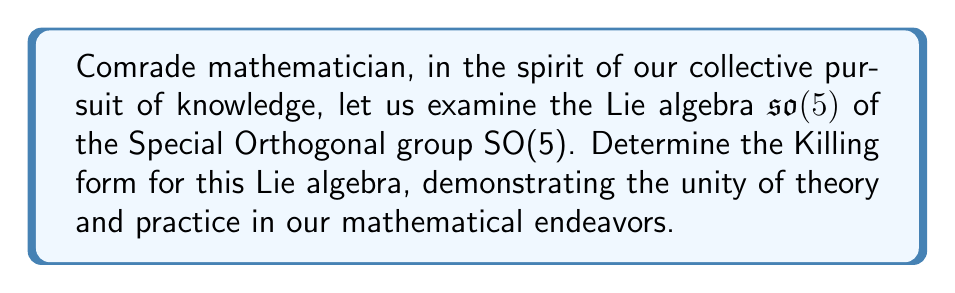Show me your answer to this math problem. Let us approach this problem step-by-step, comrade:

1) First, recall that the Killing form $B(X,Y)$ for a Lie algebra $\mathfrak{g}$ is defined as:

   $B(X,Y) = \text{tr}(\text{ad}_X \circ \text{ad}_Y)$

   where $\text{ad}_X$ is the adjoint representation of $X$.

2) For $\mathfrak{so}(5)$, we are dealing with 5x5 skew-symmetric matrices. The dimension of this Lie algebra is:

   $\dim(\mathfrak{so}(5)) = \frac{5(5-1)}{2} = 10$

3) Let's choose a basis for $\mathfrak{so}(5)$. We can use the standard basis $\{E_{ij} - E_{ji} : 1 \leq i < j \leq 5\}$, where $E_{ij}$ is the matrix with 1 in the $(i,j)$ position and 0 elsewhere.

4) For $\mathfrak{so}(5)$, the Killing form is a scalar multiple of the trace form. Specifically:

   $B(X,Y) = (n-2) \text{tr}(XY)$

   where $n$ is the dimension of the vector space on which SO(5) acts, which is 5 in this case.

5) Therefore, for $\mathfrak{so}(5)$:

   $B(X,Y) = 3 \text{tr}(XY)$

6) To express this in terms of our basis, let $X = \sum_{i<j} x_{ij}(E_{ij} - E_{ji})$ and $Y = \sum_{k<l} y_{kl}(E_{kl} - E_{lk})$. Then:

   $B(X,Y) = 3 \text{tr}(XY) = -6 \sum_{i<j} x_{ij}y_{ij}$

This is our Killing form for $\mathfrak{so}(5)$.
Answer: The Killing form for the Lie algebra $\mathfrak{so}(5)$ is:

$$B(X,Y) = 3 \text{tr}(XY) = -6 \sum_{i<j} x_{ij}y_{ij}$$

where $X = \sum_{i<j} x_{ij}(E_{ij} - E_{ji})$ and $Y = \sum_{k<l} y_{kl}(E_{kl} - E_{lk})$ are elements of $\mathfrak{so}(5)$. 